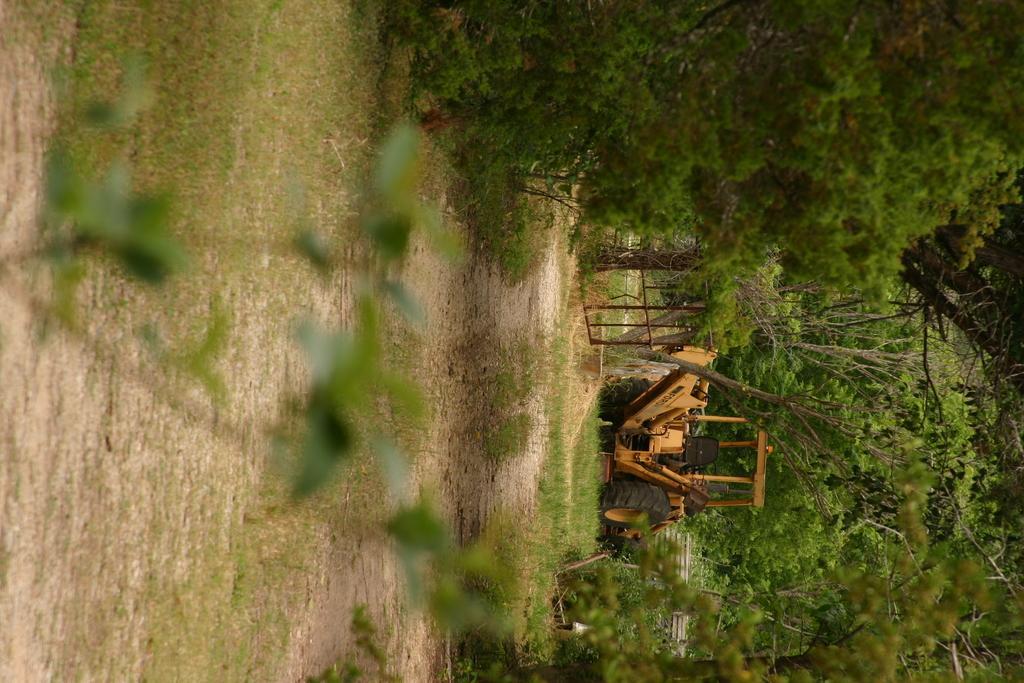In one or two sentences, can you explain what this image depicts? There is a plant, which is having green color leaves on the ground. On which, there is grass and trees. In the background, there is a excavator on the grass on the ground. 